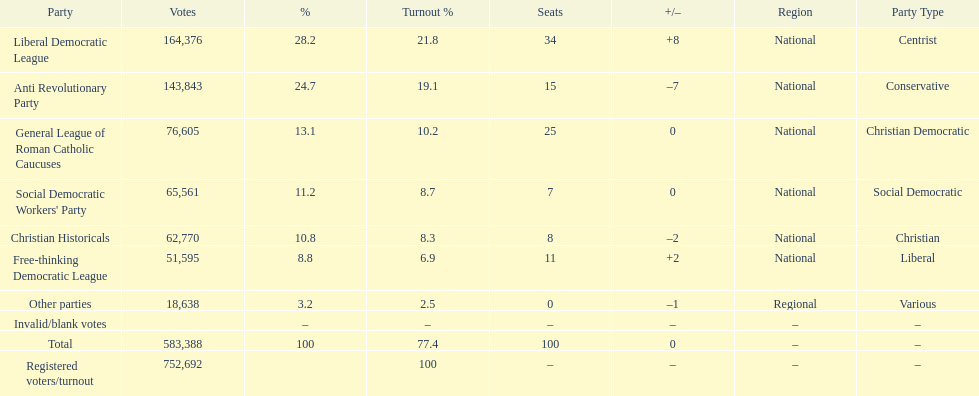Give me the full table as a dictionary. {'header': ['Party', 'Votes', '%', 'Turnout %', 'Seats', '+/–', 'Region', 'Party Type'], 'rows': [['Liberal Democratic League', '164,376', '28.2', '21.8', '34', '+8', 'National', 'Centrist'], ['Anti Revolutionary Party', '143,843', '24.7', '19.1', '15', '–7', 'National', 'Conservative'], ['General League of Roman Catholic Caucuses', '76,605', '13.1', '10.2', '25', '0', 'National', 'Christian Democratic'], ["Social Democratic Workers' Party", '65,561', '11.2', '8.7', '7', '0', 'National', 'Social Democratic'], ['Christian Historicals', '62,770', '10.8', '8.3', '8', '–2', 'National', 'Christian'], ['Free-thinking Democratic League', '51,595', '8.8', '6.9', '11', '+2', 'National', 'Liberal'], ['Other parties', '18,638', '3.2', '2.5', '0', '–1', 'Regional', 'Various'], ['Invalid/blank votes', '', '–', '–', '–', '–', '–', '–'], ['Total', '583,388', '100', '77.4', '100', '0', '–', '–'], ['Registered voters/turnout', '752,692', '', '100', '–', '–', '–', '–']]} Name the top three parties? Liberal Democratic League, Anti Revolutionary Party, General League of Roman Catholic Caucuses. 